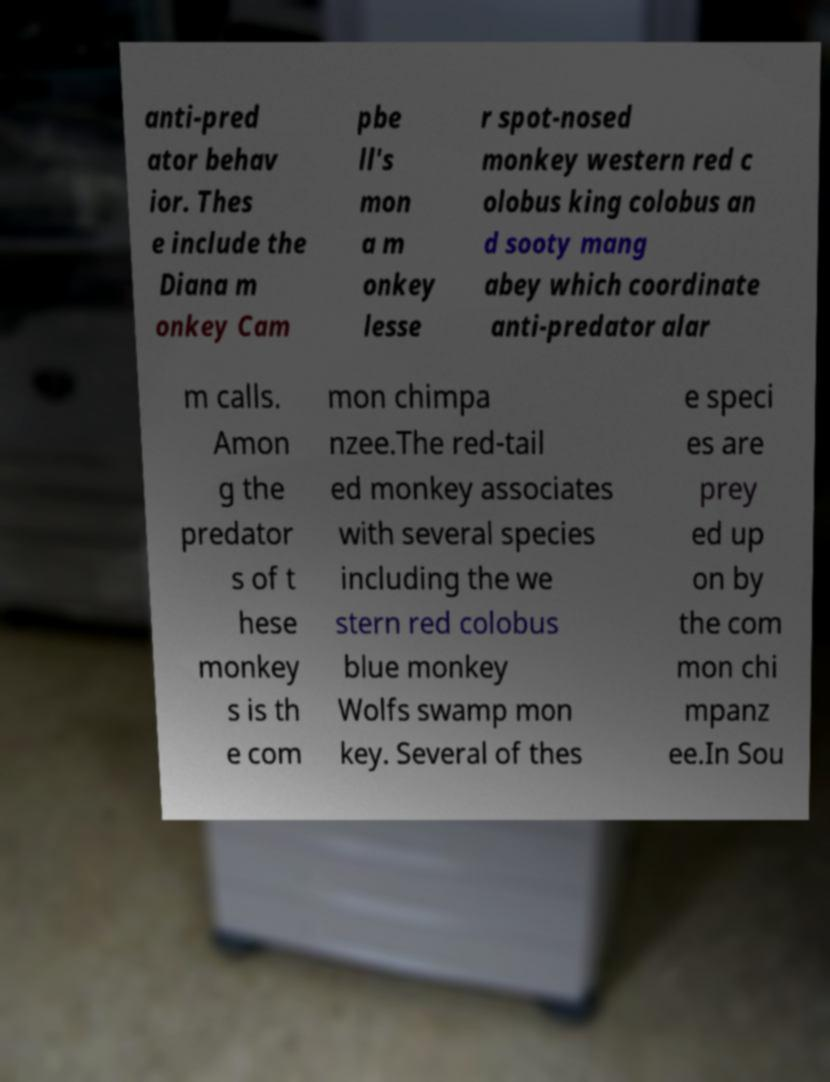Could you extract and type out the text from this image? anti-pred ator behav ior. Thes e include the Diana m onkey Cam pbe ll's mon a m onkey lesse r spot-nosed monkey western red c olobus king colobus an d sooty mang abey which coordinate anti-predator alar m calls. Amon g the predator s of t hese monkey s is th e com mon chimpa nzee.The red-tail ed monkey associates with several species including the we stern red colobus blue monkey Wolfs swamp mon key. Several of thes e speci es are prey ed up on by the com mon chi mpanz ee.In Sou 